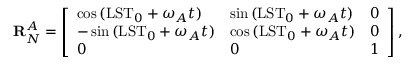<formula> <loc_0><loc_0><loc_500><loc_500>R _ { N } ^ { A } = \left [ \begin{array} { l l l } { \cos { ( L S T _ { 0 } + \omega _ { A } t ) } } & { \sin { ( L S T _ { 0 } + \omega _ { A } t ) } } & { 0 } \\ { - \sin { ( L S T _ { 0 } + \omega _ { A } t ) } } & { \cos { ( L S T _ { 0 } + \omega _ { A } t ) } } & { 0 } \\ { 0 } & { 0 } & { 1 } \end{array} \right ] ,</formula> 